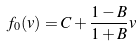<formula> <loc_0><loc_0><loc_500><loc_500>f _ { 0 } ( v ) = C + \frac { 1 - B } { 1 + B } v</formula> 